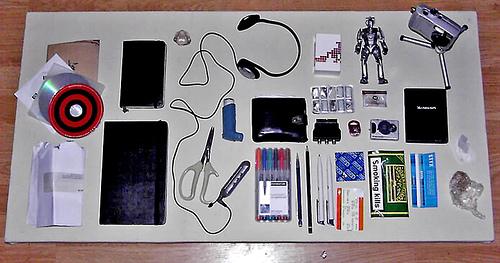What is the red and black circle object on the left?
Answer briefly. Cd. Is there a little robot on the  table?
Concise answer only. Yes. Are there pens on the table?
Short answer required. Yes. 